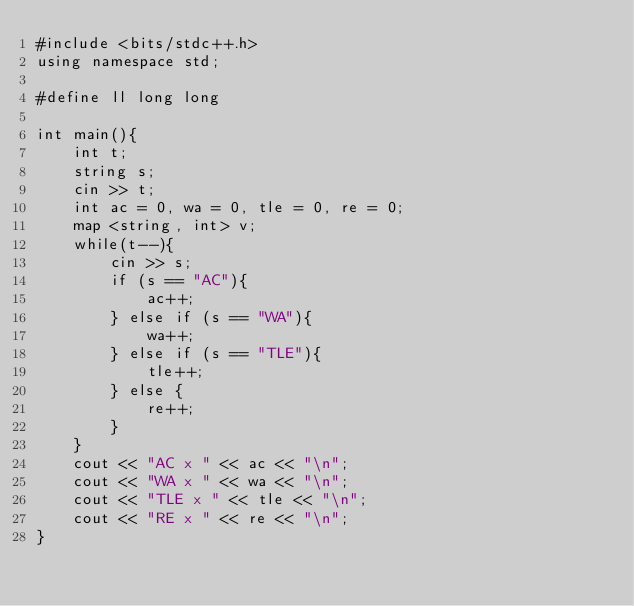Convert code to text. <code><loc_0><loc_0><loc_500><loc_500><_C++_>#include <bits/stdc++.h>
using namespace std;

#define ll long long

int main(){
	int t;
	string s;
	cin >> t;
	int ac = 0, wa = 0, tle = 0, re = 0;
	map <string, int> v;
	while(t--){
		cin >> s;
		if (s == "AC"){
			ac++;
		} else if (s == "WA"){
			wa++;
		} else if (s == "TLE"){
			tle++;
		} else {
			re++;
		}
	}
	cout << "AC x " << ac << "\n";
	cout << "WA x " << wa << "\n";
	cout << "TLE x " << tle << "\n";
	cout << "RE x " << re << "\n";
}
</code> 